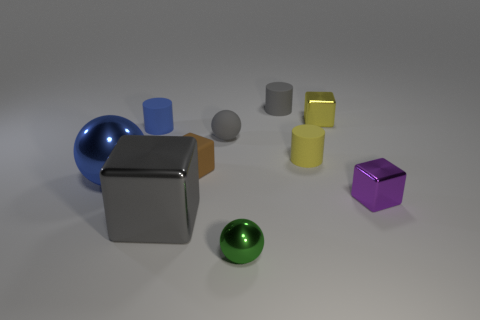Subtract all tiny yellow metal cubes. How many cubes are left? 3 Subtract all gray spheres. How many spheres are left? 2 Subtract 1 balls. How many balls are left? 2 Subtract all blocks. How many objects are left? 6 Subtract all yellow cylinders. Subtract all cyan balls. How many cylinders are left? 2 Subtract all purple cubes. How many red spheres are left? 0 Subtract all large blue shiny objects. Subtract all green objects. How many objects are left? 8 Add 8 yellow metal objects. How many yellow metal objects are left? 9 Add 3 tiny gray matte balls. How many tiny gray matte balls exist? 4 Subtract 1 gray cylinders. How many objects are left? 9 